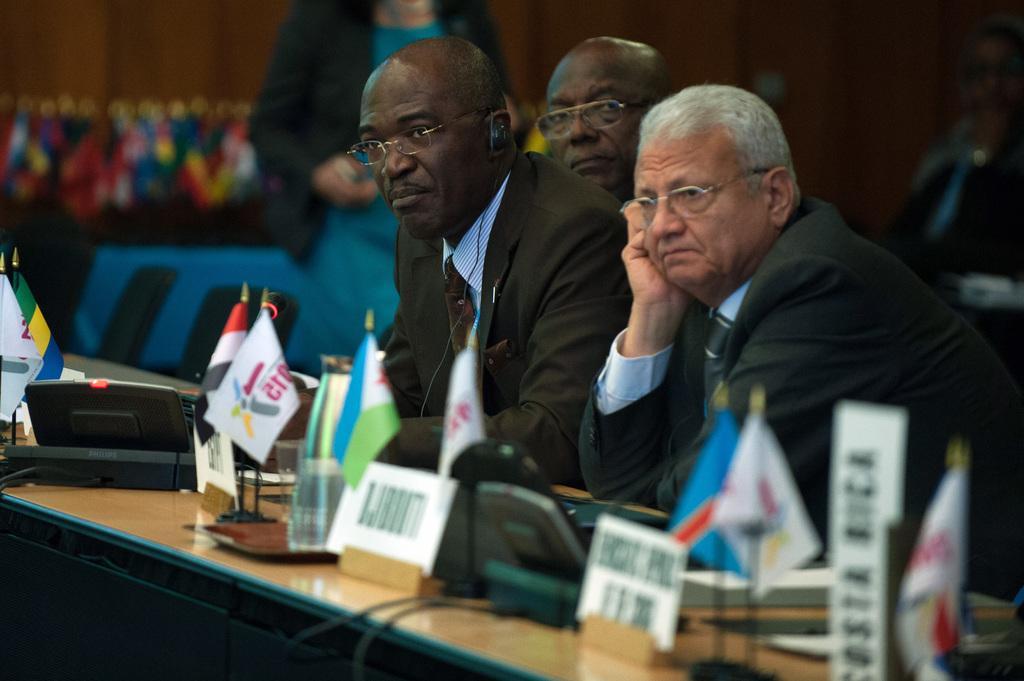Please provide a concise description of this image. In this image there are people sitting on chairs, in front of them there is a table, on that table there are flags, glasses and electrical items, in the background it is blurred. 